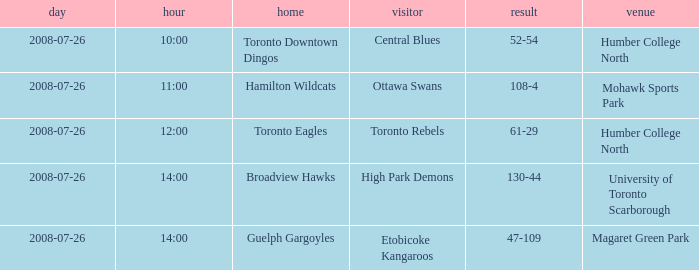The Away High Park Demons was which Ground? University of Toronto Scarborough. 